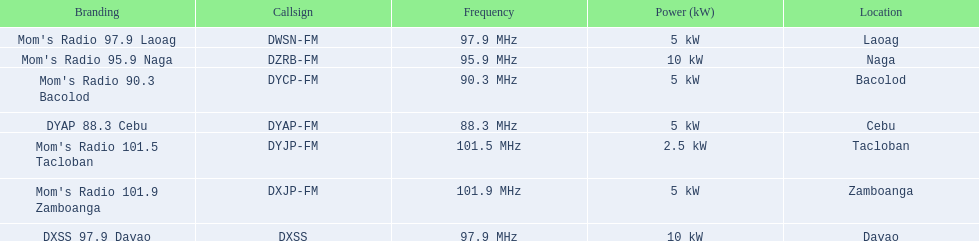Can you provide all the frequencies? 97.9 MHz, 95.9 MHz, 90.3 MHz, 88.3 MHz, 101.5 MHz, 101.9 MHz, 97.9 MHz. Which one among them is the lowest? 88.3 MHz. Which brand is associated with this specific frequency? DYAP 88.3 Cebu. 